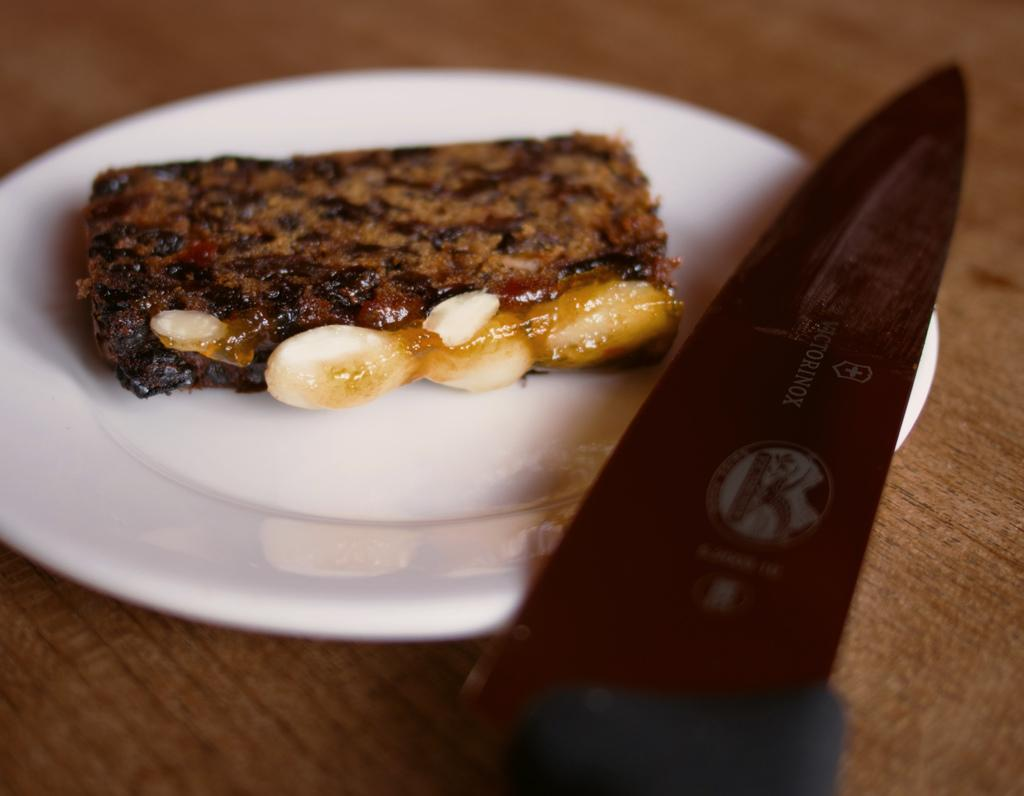What is placed on the plate in the image? There is a food item placed in a plate. What utensil is placed with the food item? There is a knife on the plate. What piece of furniture is visible in the image? There is a table in the image. What type of apples can be seen growing on the rose in the image? There are no apples or roses present in the image; it features a plate with a food item and a knife on a table. 